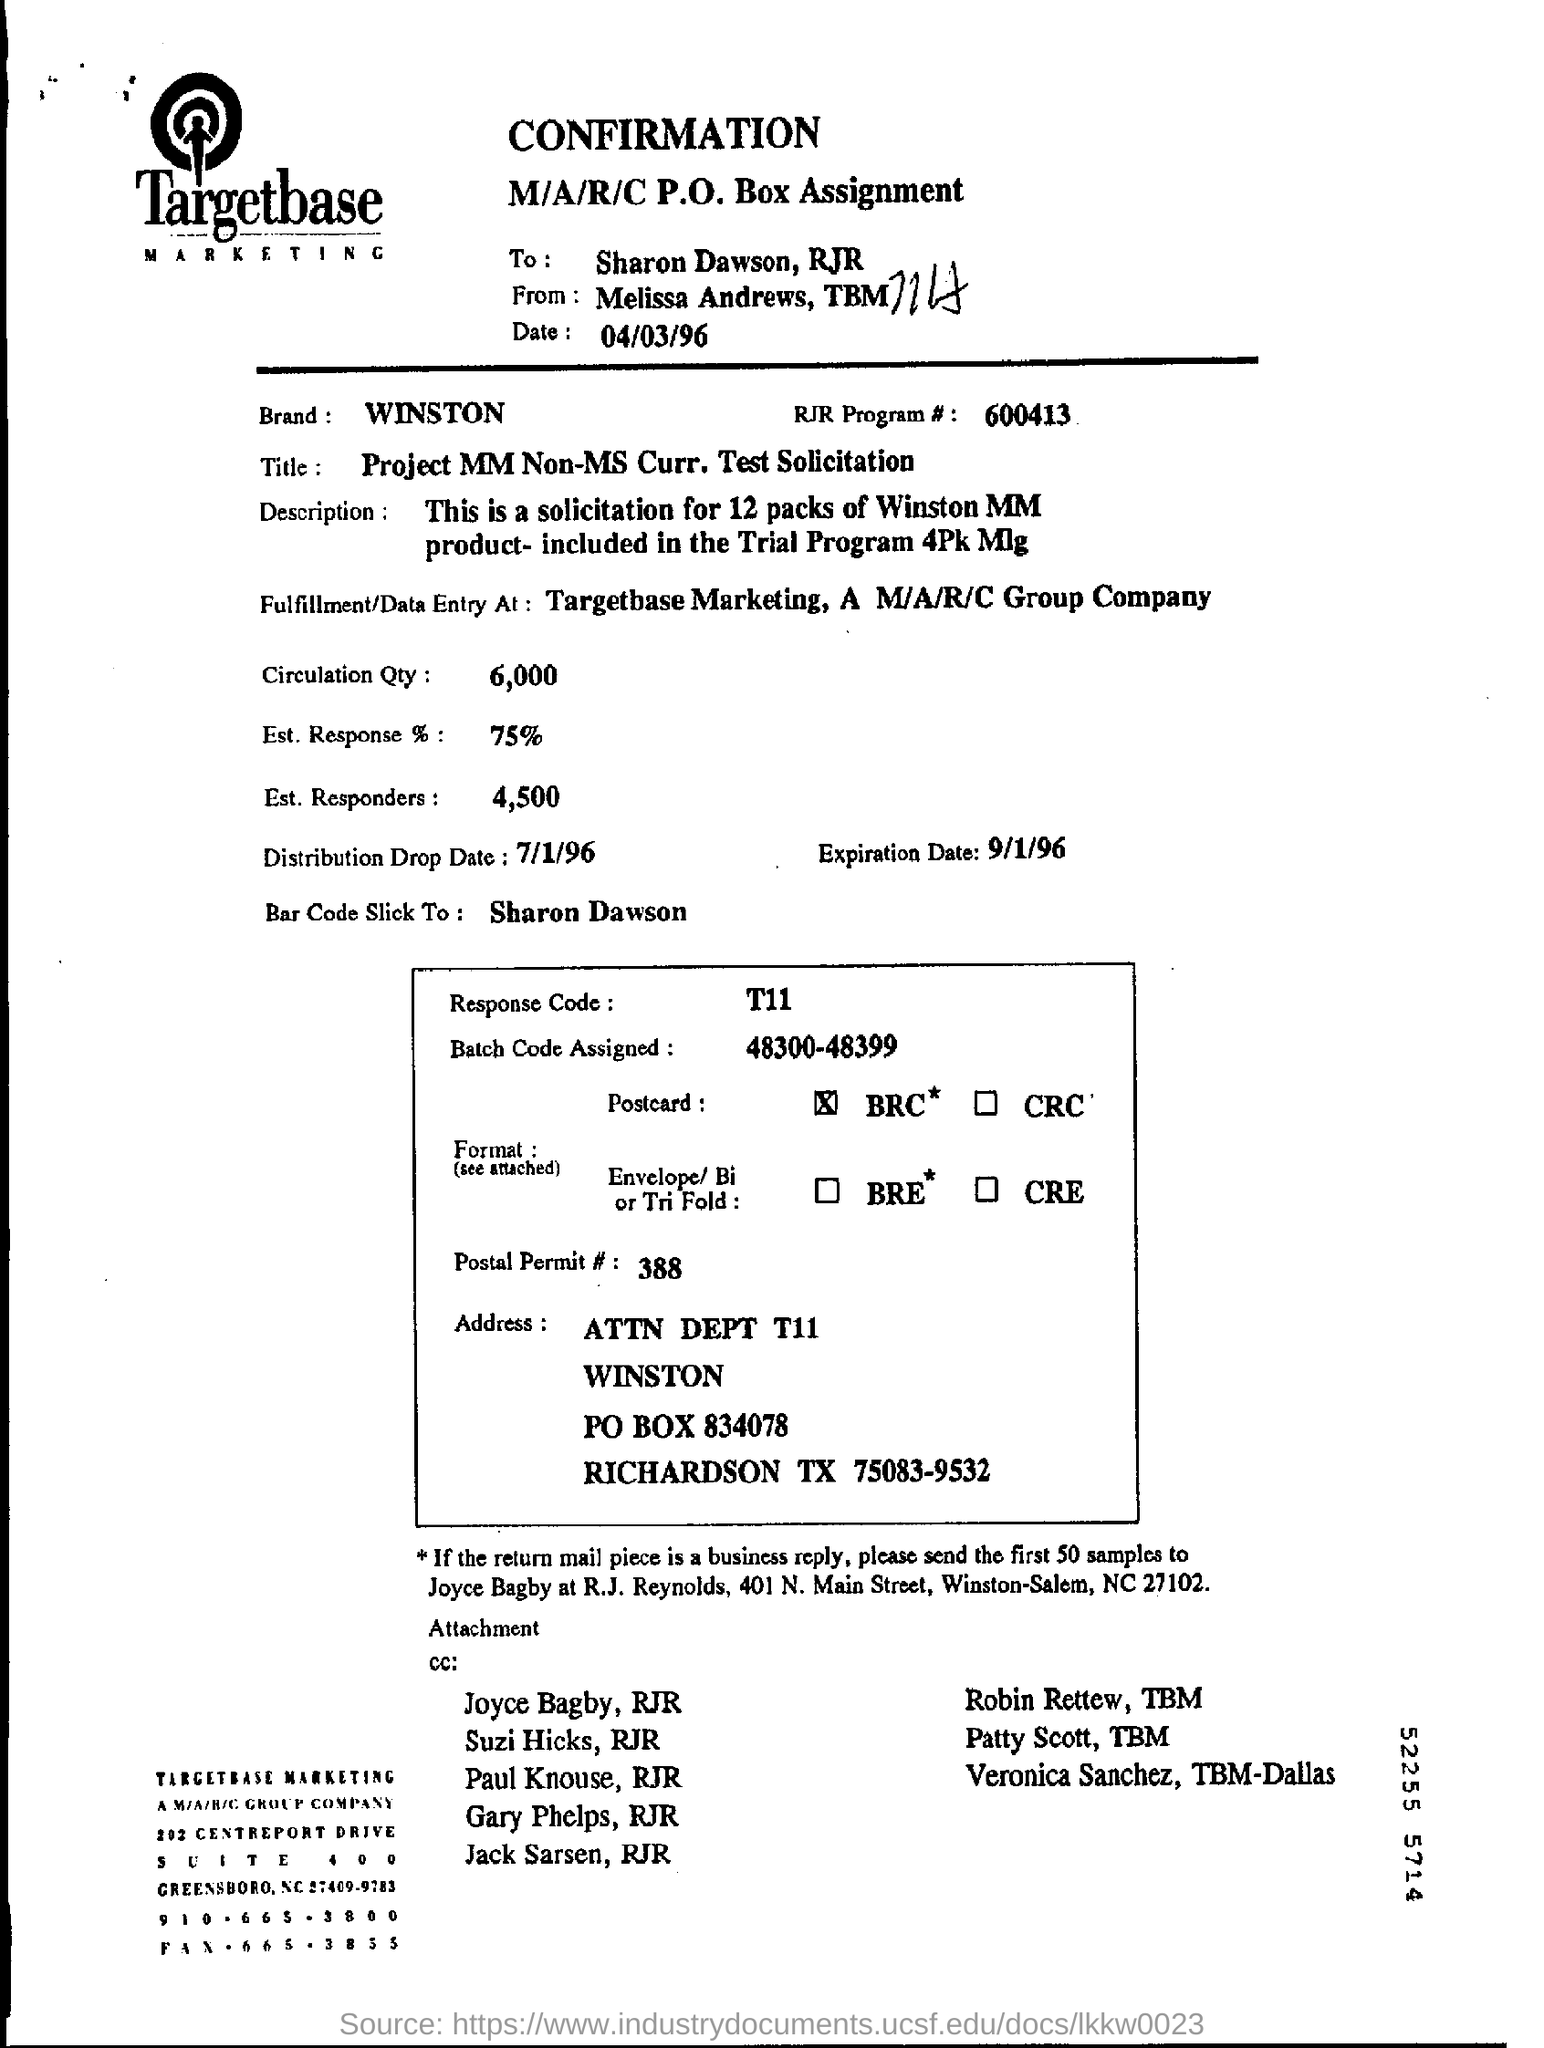What is the RJR Program# mentioned in the form?
Provide a succinct answer. 600413. What is the circulation quantity given in the form?
Keep it short and to the point. 6,000. What is the Distribution drop date mentioned in the form?
Your answer should be very brief. 7/1/96. What is the name mentioned as "Brand"?
Provide a short and direct response. WINSTON. Can you find out the "title mentioned in this paper?
Provide a succinct answer. Project mm non- ms curr. test solicitation. Please find out Circulation qty mentioned in this document?
Your answer should be compact. 6000. What is the % of Est. response?
Offer a terse response. 75%. What amount is mentioned as Est. Responders?
Keep it short and to the point. 4,500. Can you identify the distribution drop date from the document?
Keep it short and to the point. 7/1/96. Find out expiration date?
Your answer should be very brief. 9/1/96. 